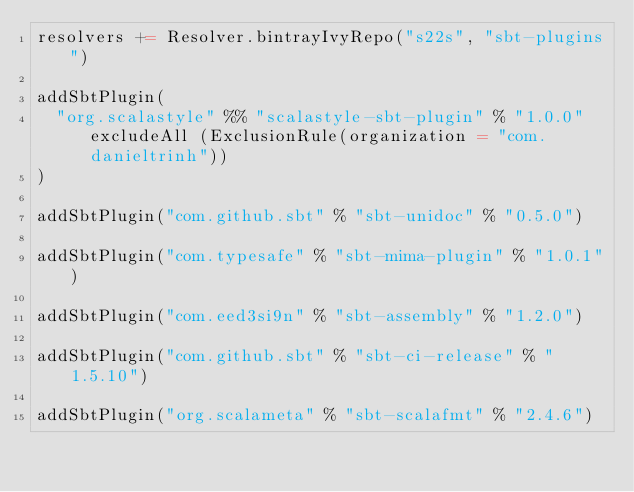Convert code to text. <code><loc_0><loc_0><loc_500><loc_500><_Scala_>resolvers += Resolver.bintrayIvyRepo("s22s", "sbt-plugins")

addSbtPlugin(
  "org.scalastyle" %% "scalastyle-sbt-plugin" % "1.0.0" excludeAll (ExclusionRule(organization = "com.danieltrinh"))
)

addSbtPlugin("com.github.sbt" % "sbt-unidoc" % "0.5.0")

addSbtPlugin("com.typesafe" % "sbt-mima-plugin" % "1.0.1")

addSbtPlugin("com.eed3si9n" % "sbt-assembly" % "1.2.0")

addSbtPlugin("com.github.sbt" % "sbt-ci-release" % "1.5.10")

addSbtPlugin("org.scalameta" % "sbt-scalafmt" % "2.4.6")
</code> 